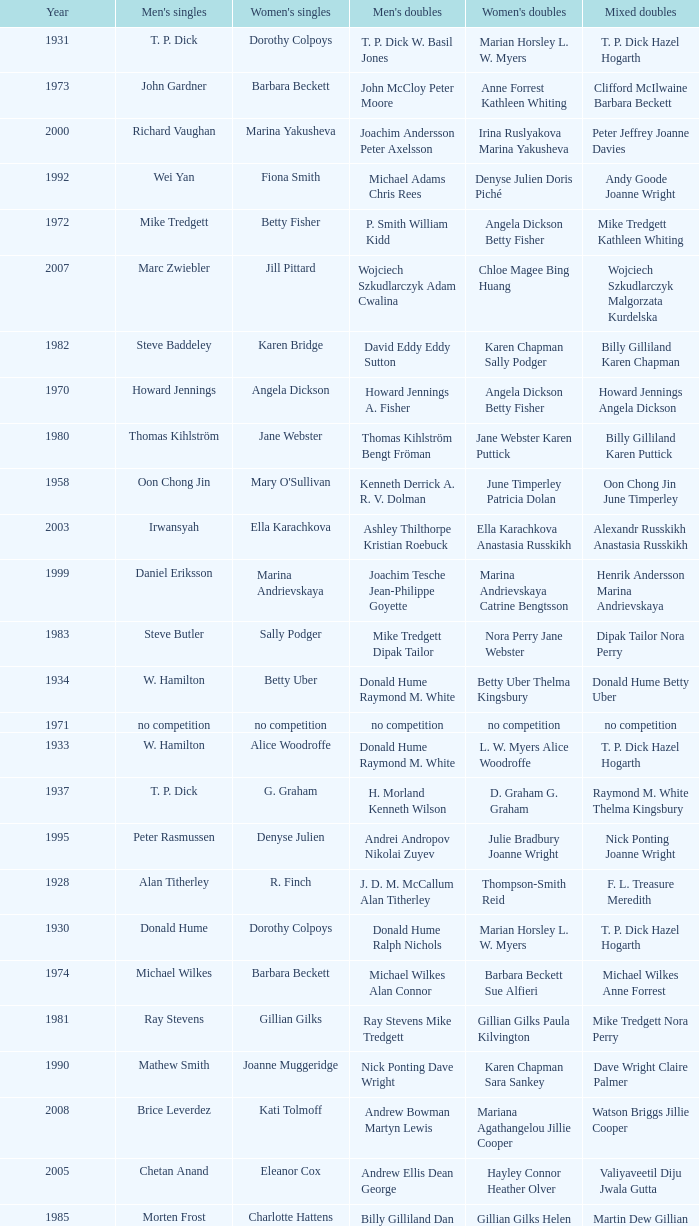Who won the Men's singles in the year that Ian Maconachie Marian Horsley won the Mixed doubles? Raymond M. White. 